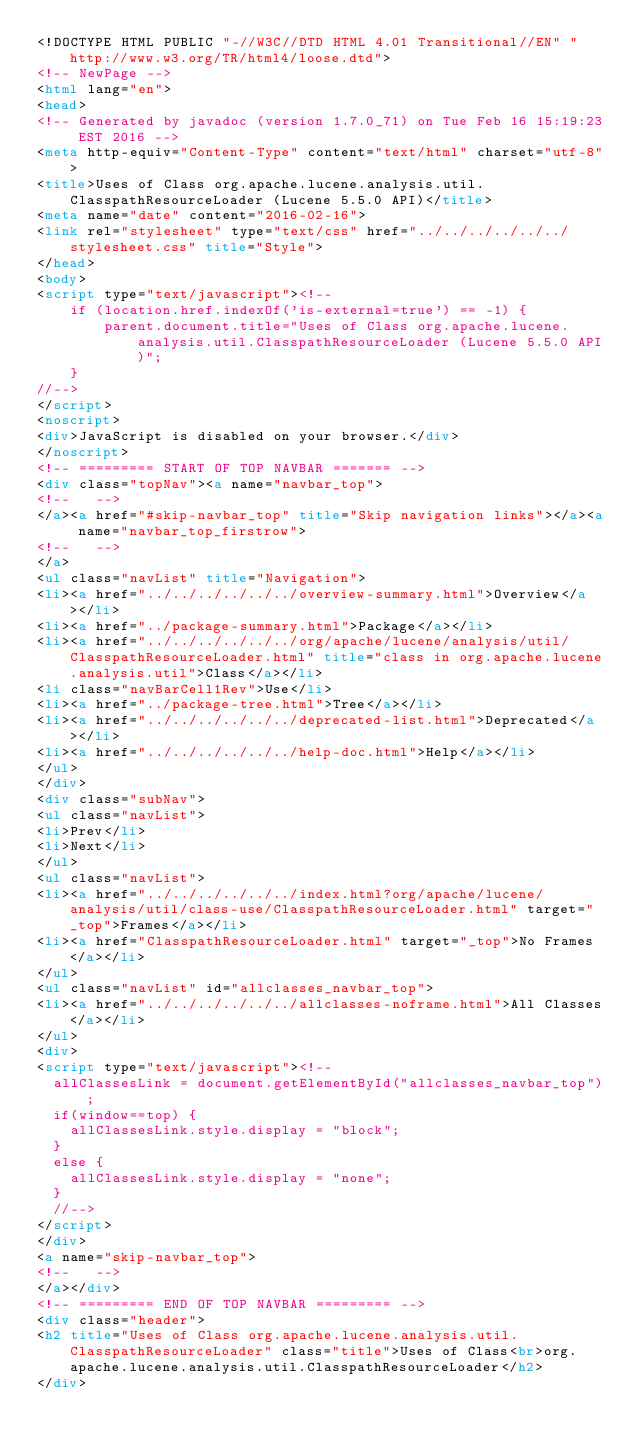Convert code to text. <code><loc_0><loc_0><loc_500><loc_500><_HTML_><!DOCTYPE HTML PUBLIC "-//W3C//DTD HTML 4.01 Transitional//EN" "http://www.w3.org/TR/html4/loose.dtd">
<!-- NewPage -->
<html lang="en">
<head>
<!-- Generated by javadoc (version 1.7.0_71) on Tue Feb 16 15:19:23 EST 2016 -->
<meta http-equiv="Content-Type" content="text/html" charset="utf-8">
<title>Uses of Class org.apache.lucene.analysis.util.ClasspathResourceLoader (Lucene 5.5.0 API)</title>
<meta name="date" content="2016-02-16">
<link rel="stylesheet" type="text/css" href="../../../../../../stylesheet.css" title="Style">
</head>
<body>
<script type="text/javascript"><!--
    if (location.href.indexOf('is-external=true') == -1) {
        parent.document.title="Uses of Class org.apache.lucene.analysis.util.ClasspathResourceLoader (Lucene 5.5.0 API)";
    }
//-->
</script>
<noscript>
<div>JavaScript is disabled on your browser.</div>
</noscript>
<!-- ========= START OF TOP NAVBAR ======= -->
<div class="topNav"><a name="navbar_top">
<!--   -->
</a><a href="#skip-navbar_top" title="Skip navigation links"></a><a name="navbar_top_firstrow">
<!--   -->
</a>
<ul class="navList" title="Navigation">
<li><a href="../../../../../../overview-summary.html">Overview</a></li>
<li><a href="../package-summary.html">Package</a></li>
<li><a href="../../../../../../org/apache/lucene/analysis/util/ClasspathResourceLoader.html" title="class in org.apache.lucene.analysis.util">Class</a></li>
<li class="navBarCell1Rev">Use</li>
<li><a href="../package-tree.html">Tree</a></li>
<li><a href="../../../../../../deprecated-list.html">Deprecated</a></li>
<li><a href="../../../../../../help-doc.html">Help</a></li>
</ul>
</div>
<div class="subNav">
<ul class="navList">
<li>Prev</li>
<li>Next</li>
</ul>
<ul class="navList">
<li><a href="../../../../../../index.html?org/apache/lucene/analysis/util/class-use/ClasspathResourceLoader.html" target="_top">Frames</a></li>
<li><a href="ClasspathResourceLoader.html" target="_top">No Frames</a></li>
</ul>
<ul class="navList" id="allclasses_navbar_top">
<li><a href="../../../../../../allclasses-noframe.html">All Classes</a></li>
</ul>
<div>
<script type="text/javascript"><!--
  allClassesLink = document.getElementById("allclasses_navbar_top");
  if(window==top) {
    allClassesLink.style.display = "block";
  }
  else {
    allClassesLink.style.display = "none";
  }
  //-->
</script>
</div>
<a name="skip-navbar_top">
<!--   -->
</a></div>
<!-- ========= END OF TOP NAVBAR ========= -->
<div class="header">
<h2 title="Uses of Class org.apache.lucene.analysis.util.ClasspathResourceLoader" class="title">Uses of Class<br>org.apache.lucene.analysis.util.ClasspathResourceLoader</h2>
</div></code> 